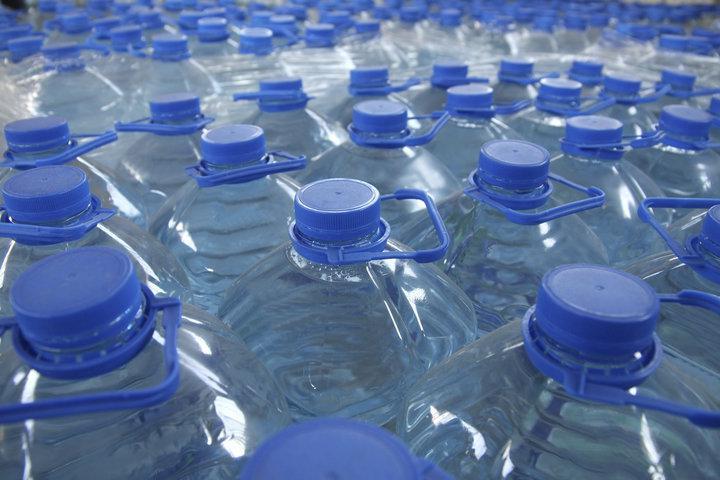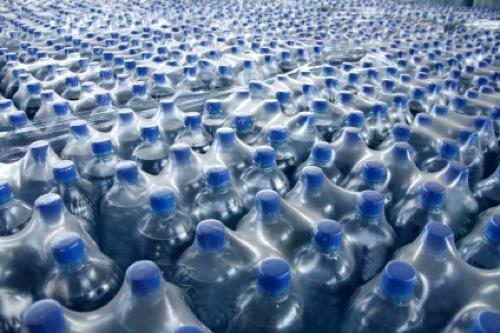The first image is the image on the left, the second image is the image on the right. Assess this claim about the two images: "An image shows barrel-shaped multi-gallon water jugs with blue lids that don't have a handle.". Correct or not? Answer yes or no. No. 